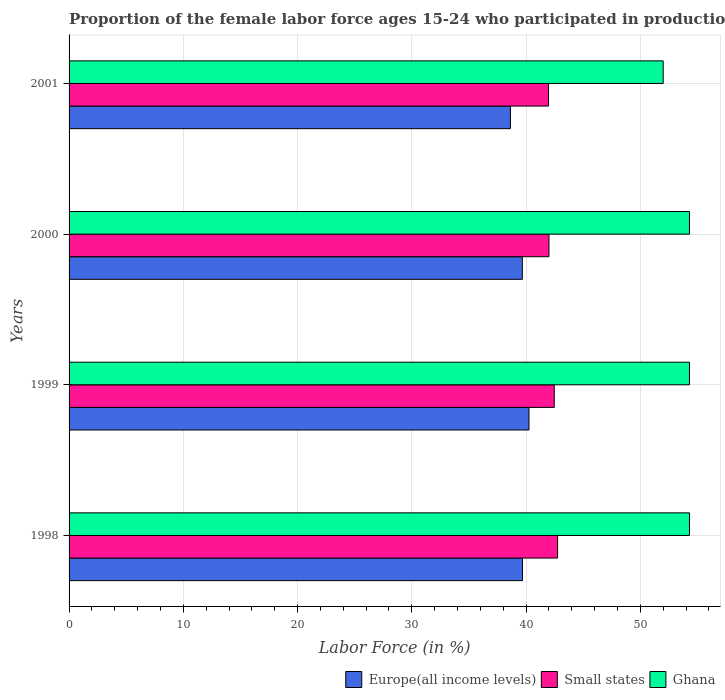How many different coloured bars are there?
Keep it short and to the point. 3. Are the number of bars per tick equal to the number of legend labels?
Give a very brief answer. Yes. Are the number of bars on each tick of the Y-axis equal?
Make the answer very short. Yes. What is the proportion of the female labor force who participated in production in Europe(all income levels) in 2000?
Give a very brief answer. 39.67. Across all years, what is the maximum proportion of the female labor force who participated in production in Europe(all income levels)?
Give a very brief answer. 40.25. Across all years, what is the minimum proportion of the female labor force who participated in production in Small states?
Your answer should be very brief. 41.96. In which year was the proportion of the female labor force who participated in production in Small states minimum?
Offer a very short reply. 2001. What is the total proportion of the female labor force who participated in production in Ghana in the graph?
Keep it short and to the point. 214.9. What is the difference between the proportion of the female labor force who participated in production in Europe(all income levels) in 1998 and that in 2001?
Provide a short and direct response. 1.05. What is the difference between the proportion of the female labor force who participated in production in Ghana in 2001 and the proportion of the female labor force who participated in production in Europe(all income levels) in 1999?
Keep it short and to the point. 11.75. What is the average proportion of the female labor force who participated in production in Ghana per year?
Offer a terse response. 53.72. In the year 2001, what is the difference between the proportion of the female labor force who participated in production in Ghana and proportion of the female labor force who participated in production in Small states?
Keep it short and to the point. 10.04. In how many years, is the proportion of the female labor force who participated in production in Small states greater than 34 %?
Offer a terse response. 4. What is the ratio of the proportion of the female labor force who participated in production in Small states in 1998 to that in 2000?
Provide a succinct answer. 1.02. What is the difference between the highest and the second highest proportion of the female labor force who participated in production in Europe(all income levels)?
Your answer should be very brief. 0.57. What is the difference between the highest and the lowest proportion of the female labor force who participated in production in Ghana?
Keep it short and to the point. 2.3. In how many years, is the proportion of the female labor force who participated in production in Ghana greater than the average proportion of the female labor force who participated in production in Ghana taken over all years?
Keep it short and to the point. 3. What does the 3rd bar from the top in 1998 represents?
Give a very brief answer. Europe(all income levels). How many bars are there?
Make the answer very short. 12. Are all the bars in the graph horizontal?
Keep it short and to the point. Yes. Does the graph contain any zero values?
Your answer should be compact. No. Where does the legend appear in the graph?
Offer a terse response. Bottom right. How many legend labels are there?
Offer a very short reply. 3. How are the legend labels stacked?
Keep it short and to the point. Horizontal. What is the title of the graph?
Make the answer very short. Proportion of the female labor force ages 15-24 who participated in production. What is the Labor Force (in %) of Europe(all income levels) in 1998?
Make the answer very short. 39.68. What is the Labor Force (in %) in Small states in 1998?
Ensure brevity in your answer.  42.76. What is the Labor Force (in %) of Ghana in 1998?
Provide a short and direct response. 54.3. What is the Labor Force (in %) of Europe(all income levels) in 1999?
Keep it short and to the point. 40.25. What is the Labor Force (in %) in Small states in 1999?
Make the answer very short. 42.46. What is the Labor Force (in %) in Ghana in 1999?
Your response must be concise. 54.3. What is the Labor Force (in %) of Europe(all income levels) in 2000?
Offer a terse response. 39.67. What is the Labor Force (in %) of Small states in 2000?
Offer a very short reply. 42. What is the Labor Force (in %) of Ghana in 2000?
Offer a very short reply. 54.3. What is the Labor Force (in %) in Europe(all income levels) in 2001?
Make the answer very short. 38.63. What is the Labor Force (in %) of Small states in 2001?
Your answer should be compact. 41.96. What is the Labor Force (in %) in Ghana in 2001?
Keep it short and to the point. 52. Across all years, what is the maximum Labor Force (in %) of Europe(all income levels)?
Offer a very short reply. 40.25. Across all years, what is the maximum Labor Force (in %) in Small states?
Your answer should be very brief. 42.76. Across all years, what is the maximum Labor Force (in %) in Ghana?
Keep it short and to the point. 54.3. Across all years, what is the minimum Labor Force (in %) in Europe(all income levels)?
Keep it short and to the point. 38.63. Across all years, what is the minimum Labor Force (in %) in Small states?
Make the answer very short. 41.96. Across all years, what is the minimum Labor Force (in %) in Ghana?
Offer a very short reply. 52. What is the total Labor Force (in %) in Europe(all income levels) in the graph?
Your answer should be very brief. 158.24. What is the total Labor Force (in %) of Small states in the graph?
Provide a succinct answer. 169.19. What is the total Labor Force (in %) in Ghana in the graph?
Offer a terse response. 214.9. What is the difference between the Labor Force (in %) in Europe(all income levels) in 1998 and that in 1999?
Provide a succinct answer. -0.57. What is the difference between the Labor Force (in %) in Small states in 1998 and that in 1999?
Ensure brevity in your answer.  0.29. What is the difference between the Labor Force (in %) in Ghana in 1998 and that in 1999?
Your answer should be compact. 0. What is the difference between the Labor Force (in %) in Europe(all income levels) in 1998 and that in 2000?
Your response must be concise. 0.01. What is the difference between the Labor Force (in %) in Small states in 1998 and that in 2000?
Provide a succinct answer. 0.75. What is the difference between the Labor Force (in %) of Europe(all income levels) in 1998 and that in 2001?
Provide a succinct answer. 1.05. What is the difference between the Labor Force (in %) of Small states in 1998 and that in 2001?
Offer a terse response. 0.79. What is the difference between the Labor Force (in %) in Ghana in 1998 and that in 2001?
Provide a succinct answer. 2.3. What is the difference between the Labor Force (in %) of Europe(all income levels) in 1999 and that in 2000?
Offer a very short reply. 0.58. What is the difference between the Labor Force (in %) of Small states in 1999 and that in 2000?
Your answer should be compact. 0.46. What is the difference between the Labor Force (in %) of Europe(all income levels) in 1999 and that in 2001?
Ensure brevity in your answer.  1.63. What is the difference between the Labor Force (in %) of Small states in 1999 and that in 2001?
Make the answer very short. 0.5. What is the difference between the Labor Force (in %) of Europe(all income levels) in 2000 and that in 2001?
Offer a terse response. 1.04. What is the difference between the Labor Force (in %) of Small states in 2000 and that in 2001?
Give a very brief answer. 0.04. What is the difference between the Labor Force (in %) of Ghana in 2000 and that in 2001?
Provide a short and direct response. 2.3. What is the difference between the Labor Force (in %) in Europe(all income levels) in 1998 and the Labor Force (in %) in Small states in 1999?
Provide a succinct answer. -2.78. What is the difference between the Labor Force (in %) of Europe(all income levels) in 1998 and the Labor Force (in %) of Ghana in 1999?
Your response must be concise. -14.62. What is the difference between the Labor Force (in %) in Small states in 1998 and the Labor Force (in %) in Ghana in 1999?
Provide a short and direct response. -11.54. What is the difference between the Labor Force (in %) of Europe(all income levels) in 1998 and the Labor Force (in %) of Small states in 2000?
Provide a succinct answer. -2.32. What is the difference between the Labor Force (in %) in Europe(all income levels) in 1998 and the Labor Force (in %) in Ghana in 2000?
Keep it short and to the point. -14.62. What is the difference between the Labor Force (in %) of Small states in 1998 and the Labor Force (in %) of Ghana in 2000?
Make the answer very short. -11.54. What is the difference between the Labor Force (in %) in Europe(all income levels) in 1998 and the Labor Force (in %) in Small states in 2001?
Provide a short and direct response. -2.28. What is the difference between the Labor Force (in %) in Europe(all income levels) in 1998 and the Labor Force (in %) in Ghana in 2001?
Provide a short and direct response. -12.32. What is the difference between the Labor Force (in %) in Small states in 1998 and the Labor Force (in %) in Ghana in 2001?
Your answer should be very brief. -9.24. What is the difference between the Labor Force (in %) of Europe(all income levels) in 1999 and the Labor Force (in %) of Small states in 2000?
Your response must be concise. -1.75. What is the difference between the Labor Force (in %) of Europe(all income levels) in 1999 and the Labor Force (in %) of Ghana in 2000?
Keep it short and to the point. -14.05. What is the difference between the Labor Force (in %) in Small states in 1999 and the Labor Force (in %) in Ghana in 2000?
Provide a short and direct response. -11.84. What is the difference between the Labor Force (in %) in Europe(all income levels) in 1999 and the Labor Force (in %) in Small states in 2001?
Provide a short and direct response. -1.71. What is the difference between the Labor Force (in %) in Europe(all income levels) in 1999 and the Labor Force (in %) in Ghana in 2001?
Your answer should be very brief. -11.75. What is the difference between the Labor Force (in %) of Small states in 1999 and the Labor Force (in %) of Ghana in 2001?
Ensure brevity in your answer.  -9.54. What is the difference between the Labor Force (in %) of Europe(all income levels) in 2000 and the Labor Force (in %) of Small states in 2001?
Provide a succinct answer. -2.29. What is the difference between the Labor Force (in %) of Europe(all income levels) in 2000 and the Labor Force (in %) of Ghana in 2001?
Your response must be concise. -12.33. What is the difference between the Labor Force (in %) in Small states in 2000 and the Labor Force (in %) in Ghana in 2001?
Your answer should be compact. -10. What is the average Labor Force (in %) in Europe(all income levels) per year?
Make the answer very short. 39.56. What is the average Labor Force (in %) of Small states per year?
Offer a terse response. 42.3. What is the average Labor Force (in %) in Ghana per year?
Keep it short and to the point. 53.73. In the year 1998, what is the difference between the Labor Force (in %) of Europe(all income levels) and Labor Force (in %) of Small states?
Your answer should be compact. -3.07. In the year 1998, what is the difference between the Labor Force (in %) of Europe(all income levels) and Labor Force (in %) of Ghana?
Ensure brevity in your answer.  -14.62. In the year 1998, what is the difference between the Labor Force (in %) of Small states and Labor Force (in %) of Ghana?
Provide a short and direct response. -11.54. In the year 1999, what is the difference between the Labor Force (in %) of Europe(all income levels) and Labor Force (in %) of Small states?
Offer a very short reply. -2.21. In the year 1999, what is the difference between the Labor Force (in %) of Europe(all income levels) and Labor Force (in %) of Ghana?
Provide a succinct answer. -14.05. In the year 1999, what is the difference between the Labor Force (in %) in Small states and Labor Force (in %) in Ghana?
Your answer should be very brief. -11.84. In the year 2000, what is the difference between the Labor Force (in %) in Europe(all income levels) and Labor Force (in %) in Small states?
Your answer should be very brief. -2.33. In the year 2000, what is the difference between the Labor Force (in %) of Europe(all income levels) and Labor Force (in %) of Ghana?
Offer a terse response. -14.63. In the year 2000, what is the difference between the Labor Force (in %) of Small states and Labor Force (in %) of Ghana?
Provide a short and direct response. -12.3. In the year 2001, what is the difference between the Labor Force (in %) in Europe(all income levels) and Labor Force (in %) in Small states?
Offer a very short reply. -3.34. In the year 2001, what is the difference between the Labor Force (in %) of Europe(all income levels) and Labor Force (in %) of Ghana?
Offer a very short reply. -13.37. In the year 2001, what is the difference between the Labor Force (in %) of Small states and Labor Force (in %) of Ghana?
Give a very brief answer. -10.04. What is the ratio of the Labor Force (in %) in Europe(all income levels) in 1998 to that in 1999?
Provide a succinct answer. 0.99. What is the ratio of the Labor Force (in %) in Europe(all income levels) in 1998 to that in 2000?
Provide a short and direct response. 1. What is the ratio of the Labor Force (in %) in Small states in 1998 to that in 2000?
Keep it short and to the point. 1.02. What is the ratio of the Labor Force (in %) of Europe(all income levels) in 1998 to that in 2001?
Keep it short and to the point. 1.03. What is the ratio of the Labor Force (in %) in Small states in 1998 to that in 2001?
Make the answer very short. 1.02. What is the ratio of the Labor Force (in %) of Ghana in 1998 to that in 2001?
Provide a succinct answer. 1.04. What is the ratio of the Labor Force (in %) of Europe(all income levels) in 1999 to that in 2000?
Provide a short and direct response. 1.01. What is the ratio of the Labor Force (in %) in Ghana in 1999 to that in 2000?
Your answer should be compact. 1. What is the ratio of the Labor Force (in %) of Europe(all income levels) in 1999 to that in 2001?
Your answer should be very brief. 1.04. What is the ratio of the Labor Force (in %) of Small states in 1999 to that in 2001?
Ensure brevity in your answer.  1.01. What is the ratio of the Labor Force (in %) of Ghana in 1999 to that in 2001?
Your response must be concise. 1.04. What is the ratio of the Labor Force (in %) in Ghana in 2000 to that in 2001?
Give a very brief answer. 1.04. What is the difference between the highest and the second highest Labor Force (in %) of Europe(all income levels)?
Provide a succinct answer. 0.57. What is the difference between the highest and the second highest Labor Force (in %) of Small states?
Your response must be concise. 0.29. What is the difference between the highest and the second highest Labor Force (in %) in Ghana?
Ensure brevity in your answer.  0. What is the difference between the highest and the lowest Labor Force (in %) in Europe(all income levels)?
Provide a short and direct response. 1.63. What is the difference between the highest and the lowest Labor Force (in %) in Small states?
Provide a succinct answer. 0.79. 